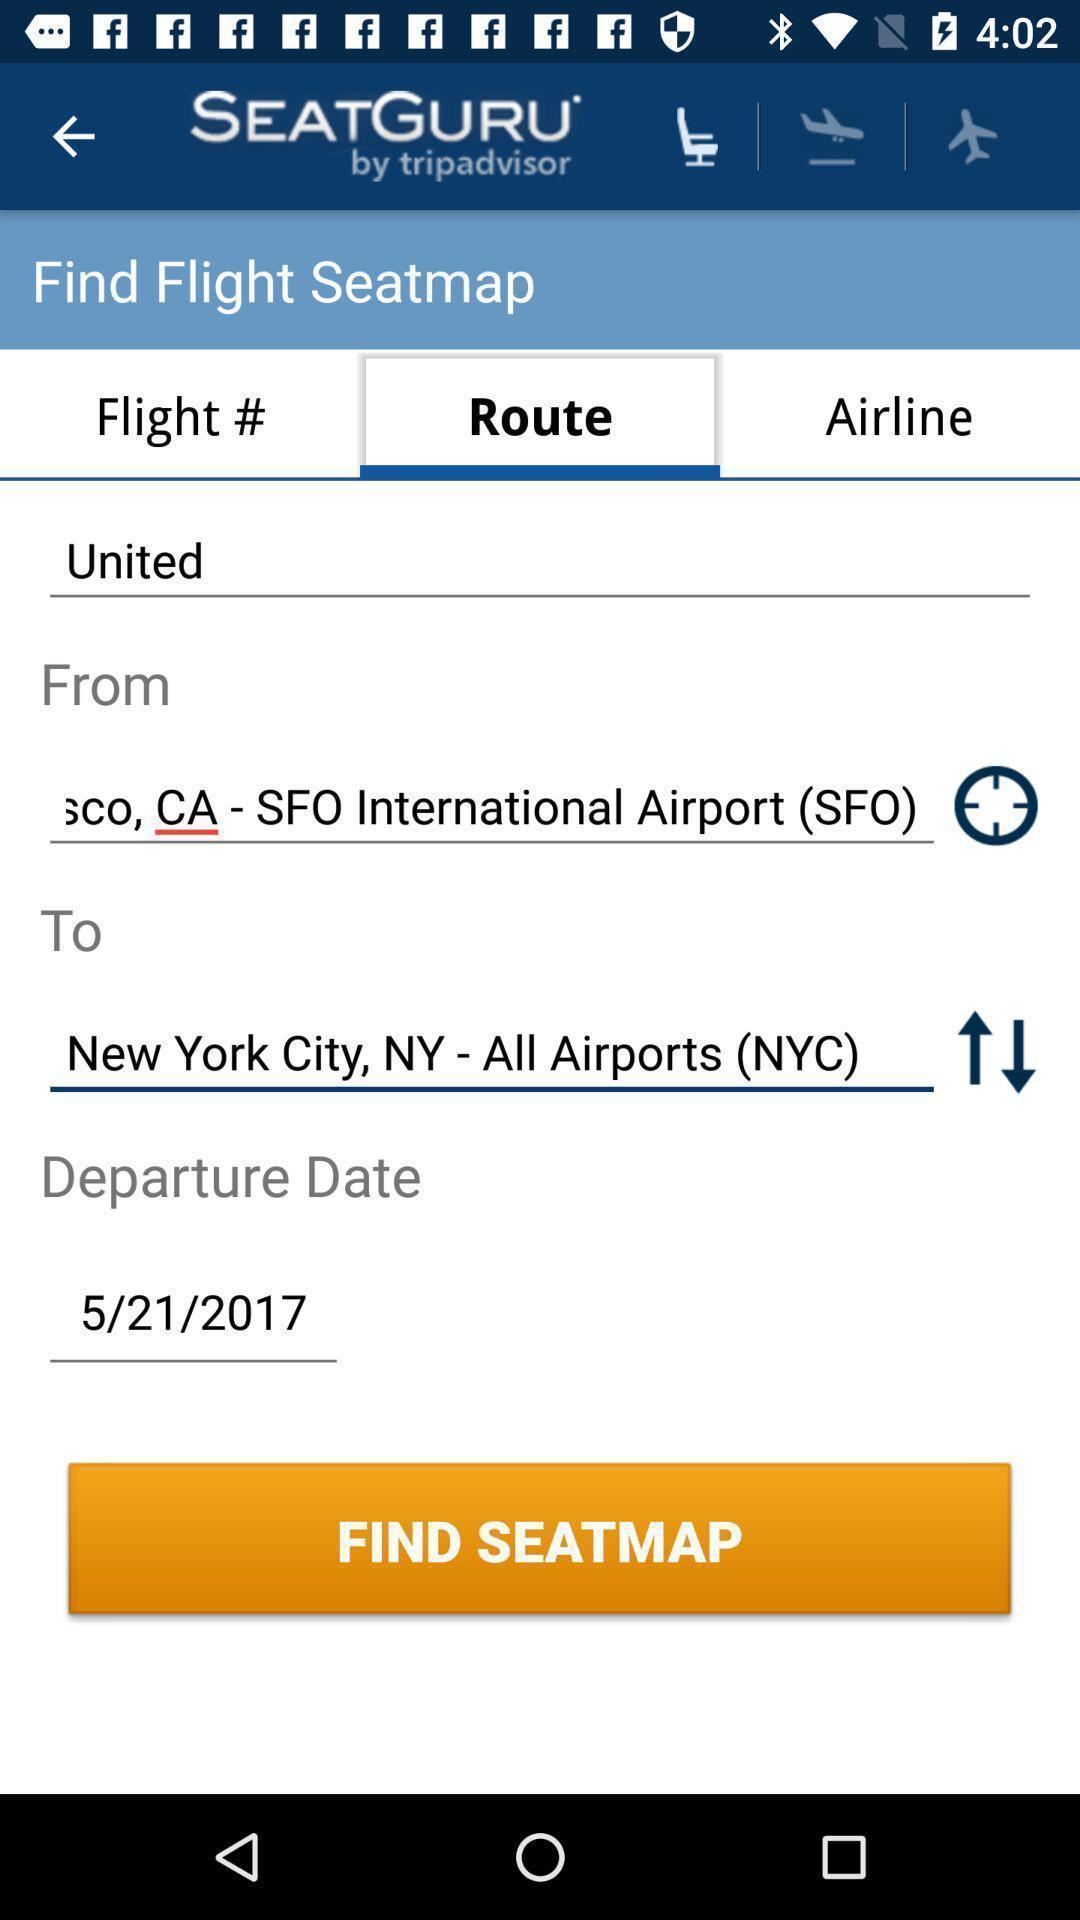Give me a summary of this screen capture. Screen showing search bar to find seat map. 